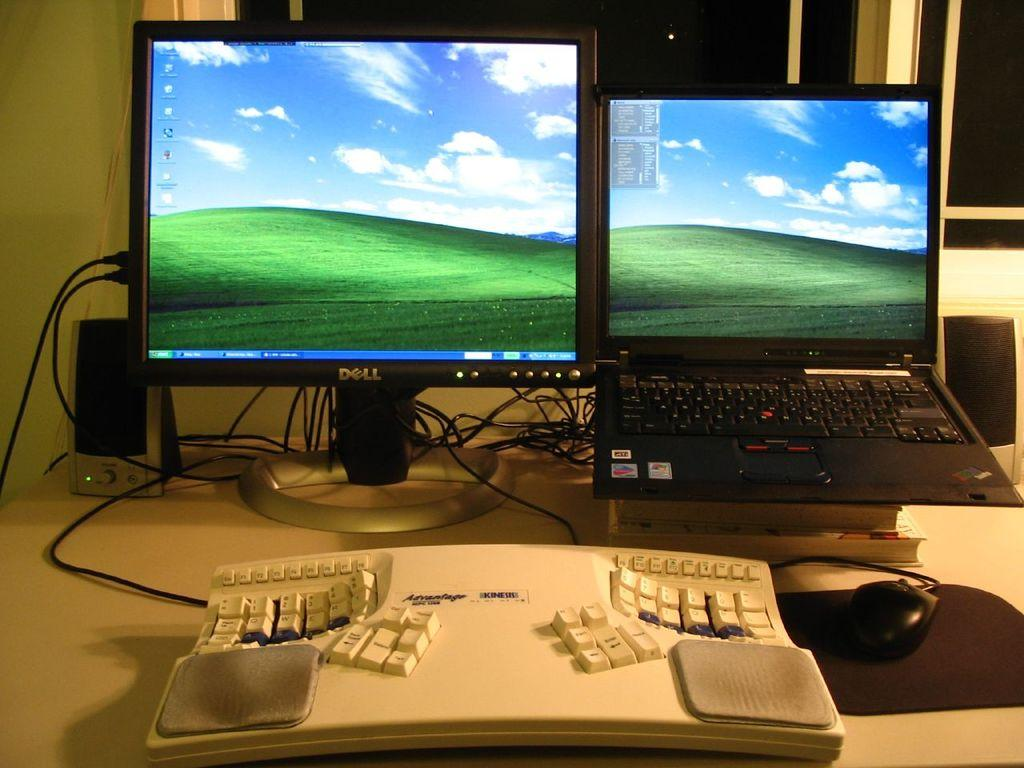<image>
Share a concise interpretation of the image provided. A dell monitor next to a IBM laptop witha kiness keyboard in front. 